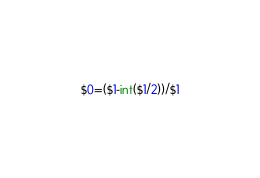<code> <loc_0><loc_0><loc_500><loc_500><_Awk_>$0=($1-int($1/2))/$1</code> 